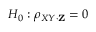Convert formula to latex. <formula><loc_0><loc_0><loc_500><loc_500>H _ { 0 } \colon \rho _ { X Y \cdot Z } = 0</formula> 